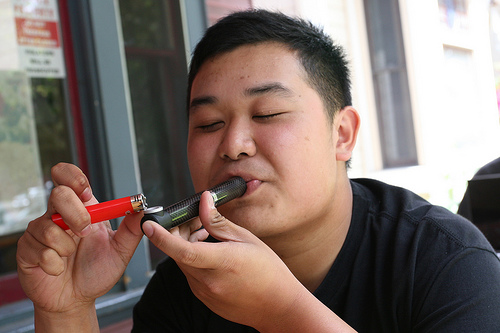<image>
Can you confirm if the man is next to the lighter? Yes. The man is positioned adjacent to the lighter, located nearby in the same general area. 